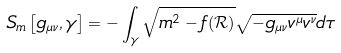Convert formula to latex. <formula><loc_0><loc_0><loc_500><loc_500>S _ { m } \left [ g _ { \mu \nu } , \gamma \right ] = - \int _ { \gamma } \sqrt { m ^ { 2 } - f ( \mathcal { R } ) } \sqrt { - g _ { \mu \nu } v ^ { \mu } v ^ { \nu } } d \tau</formula> 